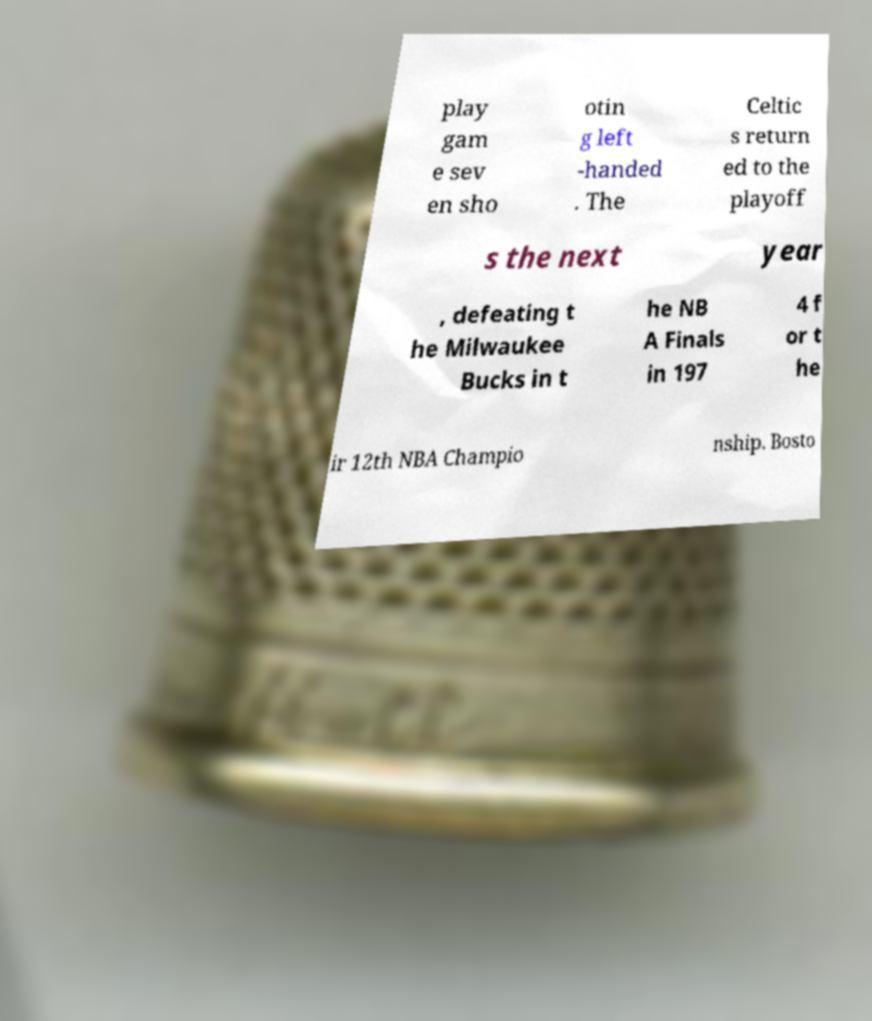For documentation purposes, I need the text within this image transcribed. Could you provide that? play gam e sev en sho otin g left -handed . The Celtic s return ed to the playoff s the next year , defeating t he Milwaukee Bucks in t he NB A Finals in 197 4 f or t he ir 12th NBA Champio nship. Bosto 